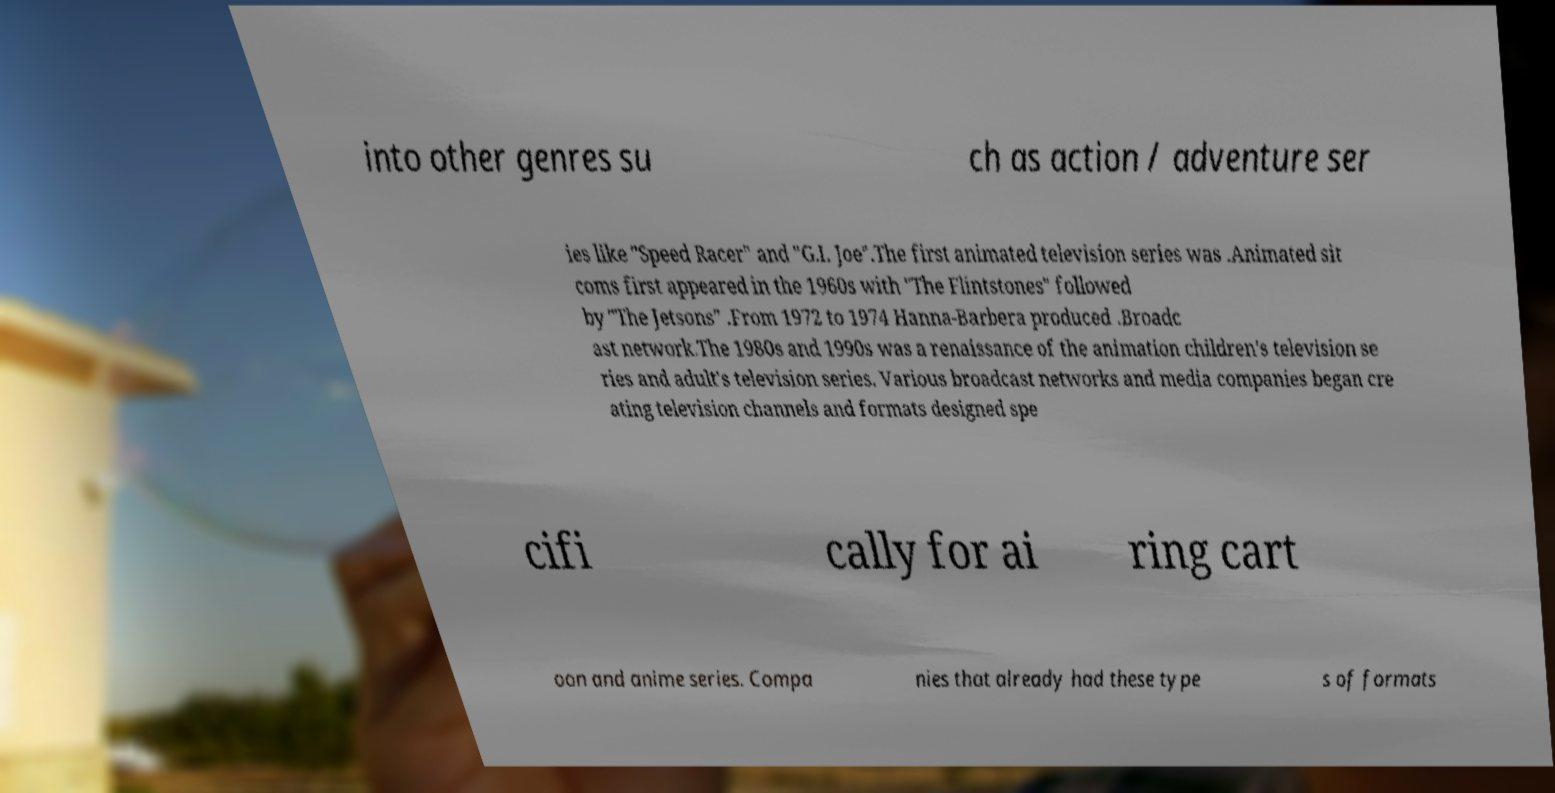There's text embedded in this image that I need extracted. Can you transcribe it verbatim? into other genres su ch as action / adventure ser ies like "Speed Racer" and "G.I. Joe".The first animated television series was .Animated sit coms first appeared in the 1960s with "The Flintstones" followed by "The Jetsons" .From 1972 to 1974 Hanna-Barbera produced .Broadc ast network.The 1980s and 1990s was a renaissance of the animation children's television se ries and adult's television series. Various broadcast networks and media companies began cre ating television channels and formats designed spe cifi cally for ai ring cart oon and anime series. Compa nies that already had these type s of formats 